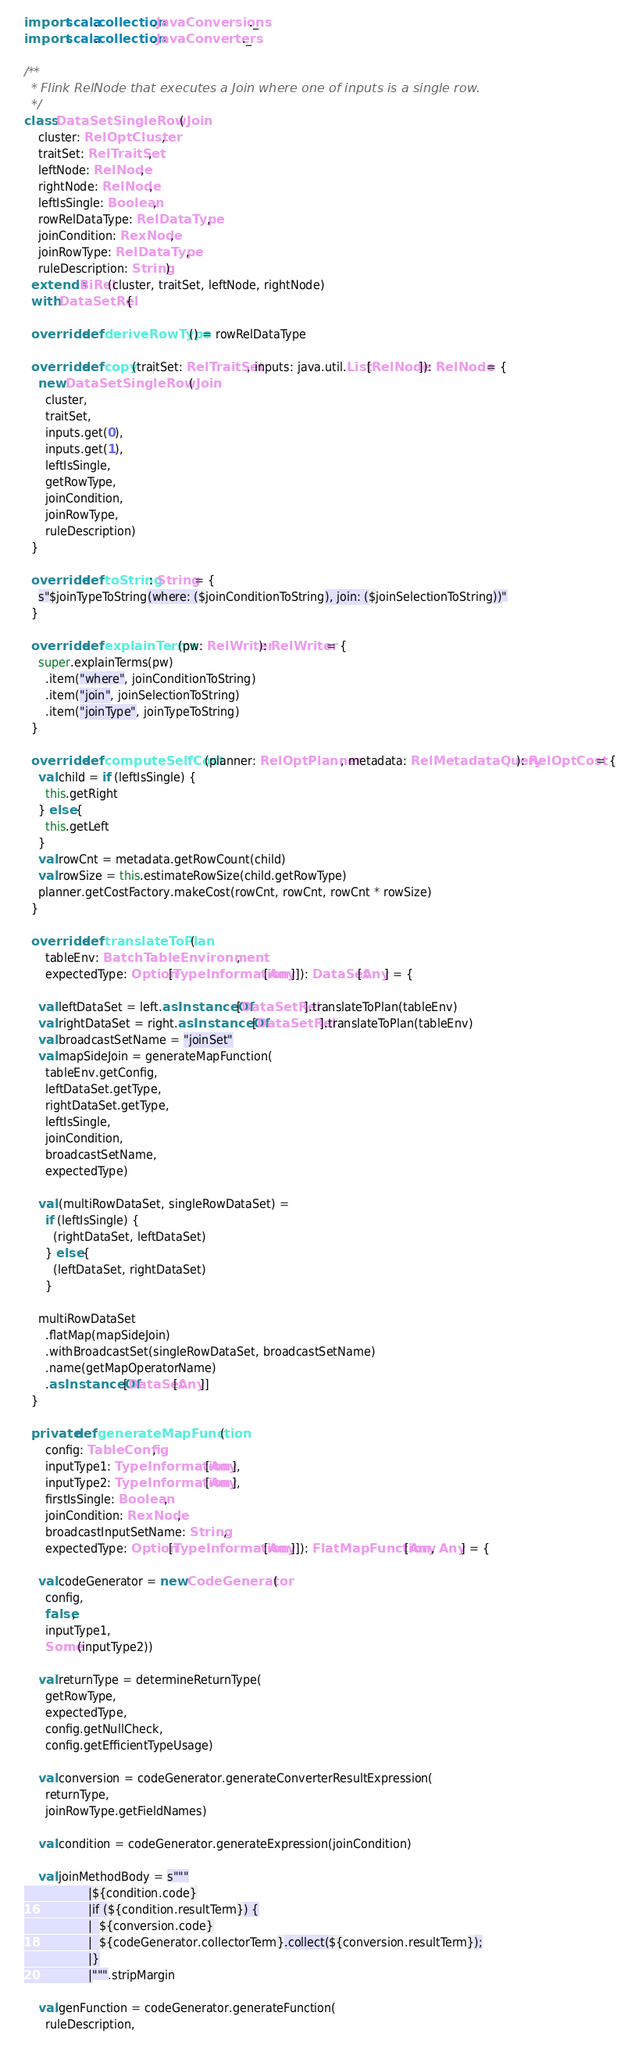Convert code to text. <code><loc_0><loc_0><loc_500><loc_500><_Scala_>
import scala.collection.JavaConversions._
import scala.collection.JavaConverters._

/**
  * Flink RelNode that executes a Join where one of inputs is a single row.
  */
class DataSetSingleRowJoin(
    cluster: RelOptCluster,
    traitSet: RelTraitSet,
    leftNode: RelNode,
    rightNode: RelNode,
    leftIsSingle: Boolean,
    rowRelDataType: RelDataType,
    joinCondition: RexNode,
    joinRowType: RelDataType,
    ruleDescription: String)
  extends BiRel(cluster, traitSet, leftNode, rightNode)
  with DataSetRel {

  override def deriveRowType() = rowRelDataType

  override def copy(traitSet: RelTraitSet, inputs: java.util.List[RelNode]): RelNode = {
    new DataSetSingleRowJoin(
      cluster,
      traitSet,
      inputs.get(0),
      inputs.get(1),
      leftIsSingle,
      getRowType,
      joinCondition,
      joinRowType,
      ruleDescription)
  }

  override def toString: String = {
    s"$joinTypeToString(where: ($joinConditionToString), join: ($joinSelectionToString))"
  }

  override def explainTerms(pw: RelWriter): RelWriter = {
    super.explainTerms(pw)
      .item("where", joinConditionToString)
      .item("join", joinSelectionToString)
      .item("joinType", joinTypeToString)
  }

  override def computeSelfCost (planner: RelOptPlanner, metadata: RelMetadataQuery): RelOptCost = {
    val child = if (leftIsSingle) {
      this.getRight
    } else {
      this.getLeft
    }
    val rowCnt = metadata.getRowCount(child)
    val rowSize = this.estimateRowSize(child.getRowType)
    planner.getCostFactory.makeCost(rowCnt, rowCnt, rowCnt * rowSize)
  }

  override def translateToPlan(
      tableEnv: BatchTableEnvironment,
      expectedType: Option[TypeInformation[Any]]): DataSet[Any] = {

    val leftDataSet = left.asInstanceOf[DataSetRel].translateToPlan(tableEnv)
    val rightDataSet = right.asInstanceOf[DataSetRel].translateToPlan(tableEnv)
    val broadcastSetName = "joinSet"
    val mapSideJoin = generateMapFunction(
      tableEnv.getConfig,
      leftDataSet.getType,
      rightDataSet.getType,
      leftIsSingle,
      joinCondition,
      broadcastSetName,
      expectedType)

    val (multiRowDataSet, singleRowDataSet) =
      if (leftIsSingle) {
        (rightDataSet, leftDataSet)
      } else {
        (leftDataSet, rightDataSet)
      }

    multiRowDataSet
      .flatMap(mapSideJoin)
      .withBroadcastSet(singleRowDataSet, broadcastSetName)
      .name(getMapOperatorName)
      .asInstanceOf[DataSet[Any]]
  }

  private def generateMapFunction(
      config: TableConfig,
      inputType1: TypeInformation[Any],
      inputType2: TypeInformation[Any],
      firstIsSingle: Boolean,
      joinCondition: RexNode,
      broadcastInputSetName: String,
      expectedType: Option[TypeInformation[Any]]): FlatMapFunction[Any, Any] = {

    val codeGenerator = new CodeGenerator(
      config,
      false,
      inputType1,
      Some(inputType2))

    val returnType = determineReturnType(
      getRowType,
      expectedType,
      config.getNullCheck,
      config.getEfficientTypeUsage)

    val conversion = codeGenerator.generateConverterResultExpression(
      returnType,
      joinRowType.getFieldNames)

    val condition = codeGenerator.generateExpression(joinCondition)

    val joinMethodBody = s"""
                  |${condition.code}
                  |if (${condition.resultTerm}) {
                  |  ${conversion.code}
                  |  ${codeGenerator.collectorTerm}.collect(${conversion.resultTerm});
                  |}
                  |""".stripMargin

    val genFunction = codeGenerator.generateFunction(
      ruleDescription,</code> 